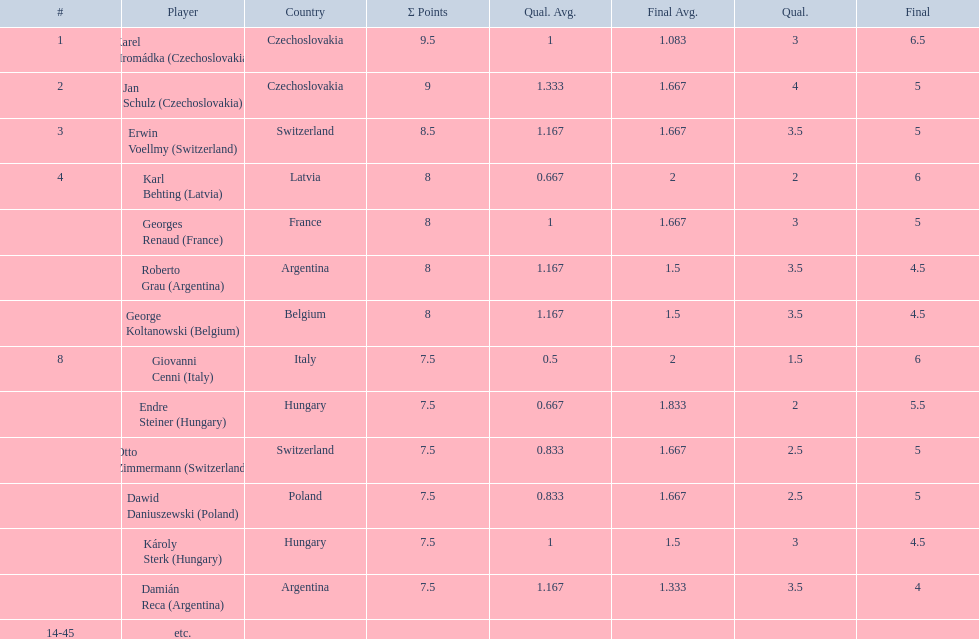Karl behting and giovanni cenni each had final scores of what? 6. 